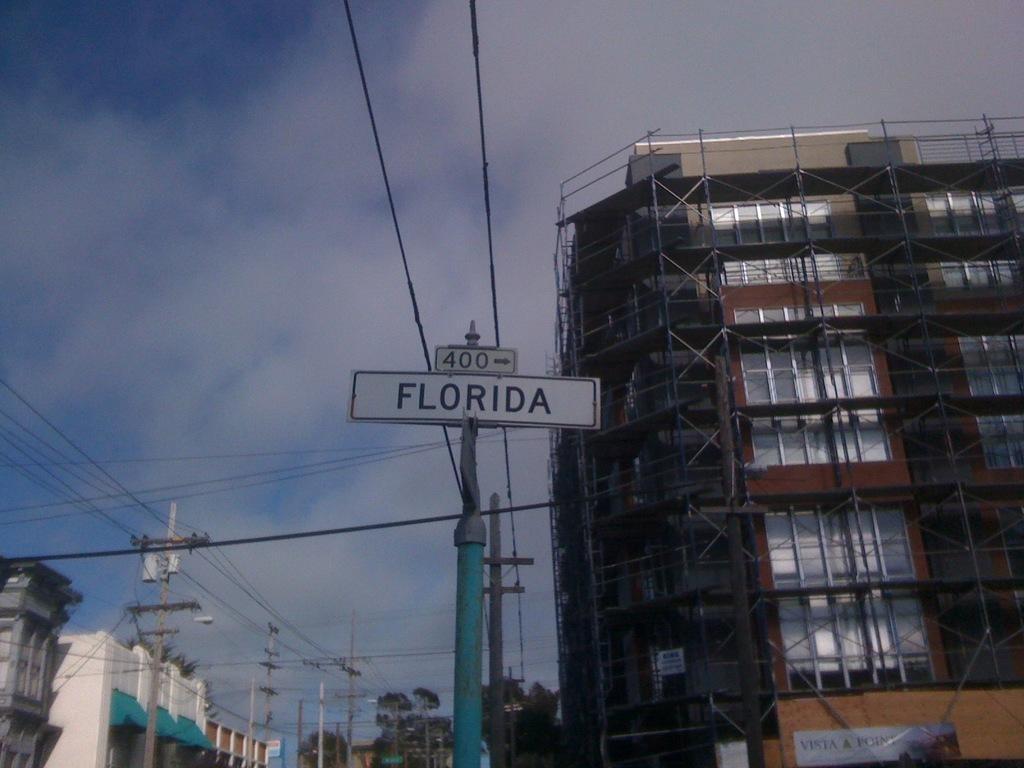Can you describe this image briefly? This image consists of a buildings. In the middle, we can see the poles and a board along with the wires. At the top, there are clouds in the sky. 